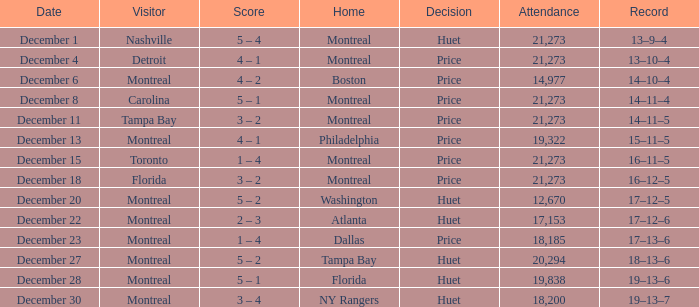What is the score when Philadelphia is at home? 4 – 1. 